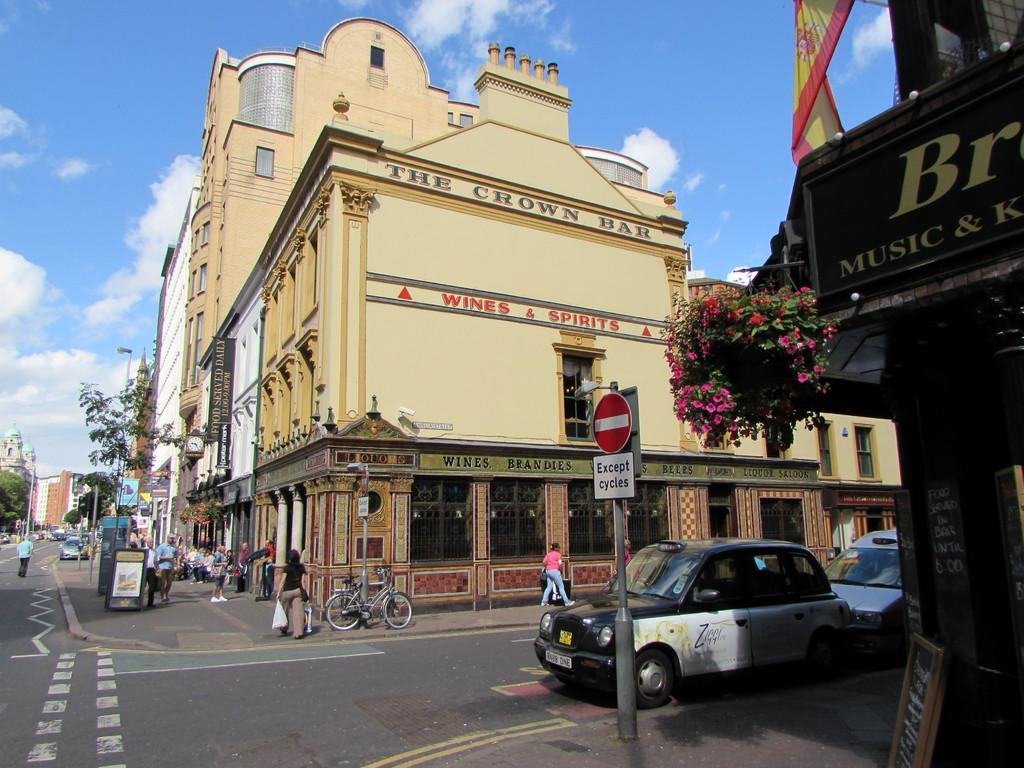<image>
Offer a succinct explanation of the picture presented. A street corner has a sign that says Except cycles. 